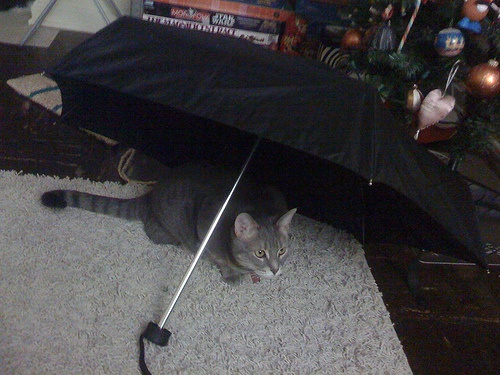Describe the objects in this image and their specific colors. I can see umbrella in black, navy, and gray tones, cat in black, gray, and darkgray tones, book in black, gray, navy, and purple tones, book in black, gray, darkgray, and purple tones, and book in black, brown, and maroon tones in this image. 